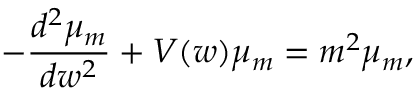<formula> <loc_0><loc_0><loc_500><loc_500>- \frac { d ^ { 2 } \mu _ { m } } { d w ^ { 2 } } + V ( w ) \mu _ { m } = m ^ { 2 } \mu _ { m } ,</formula> 